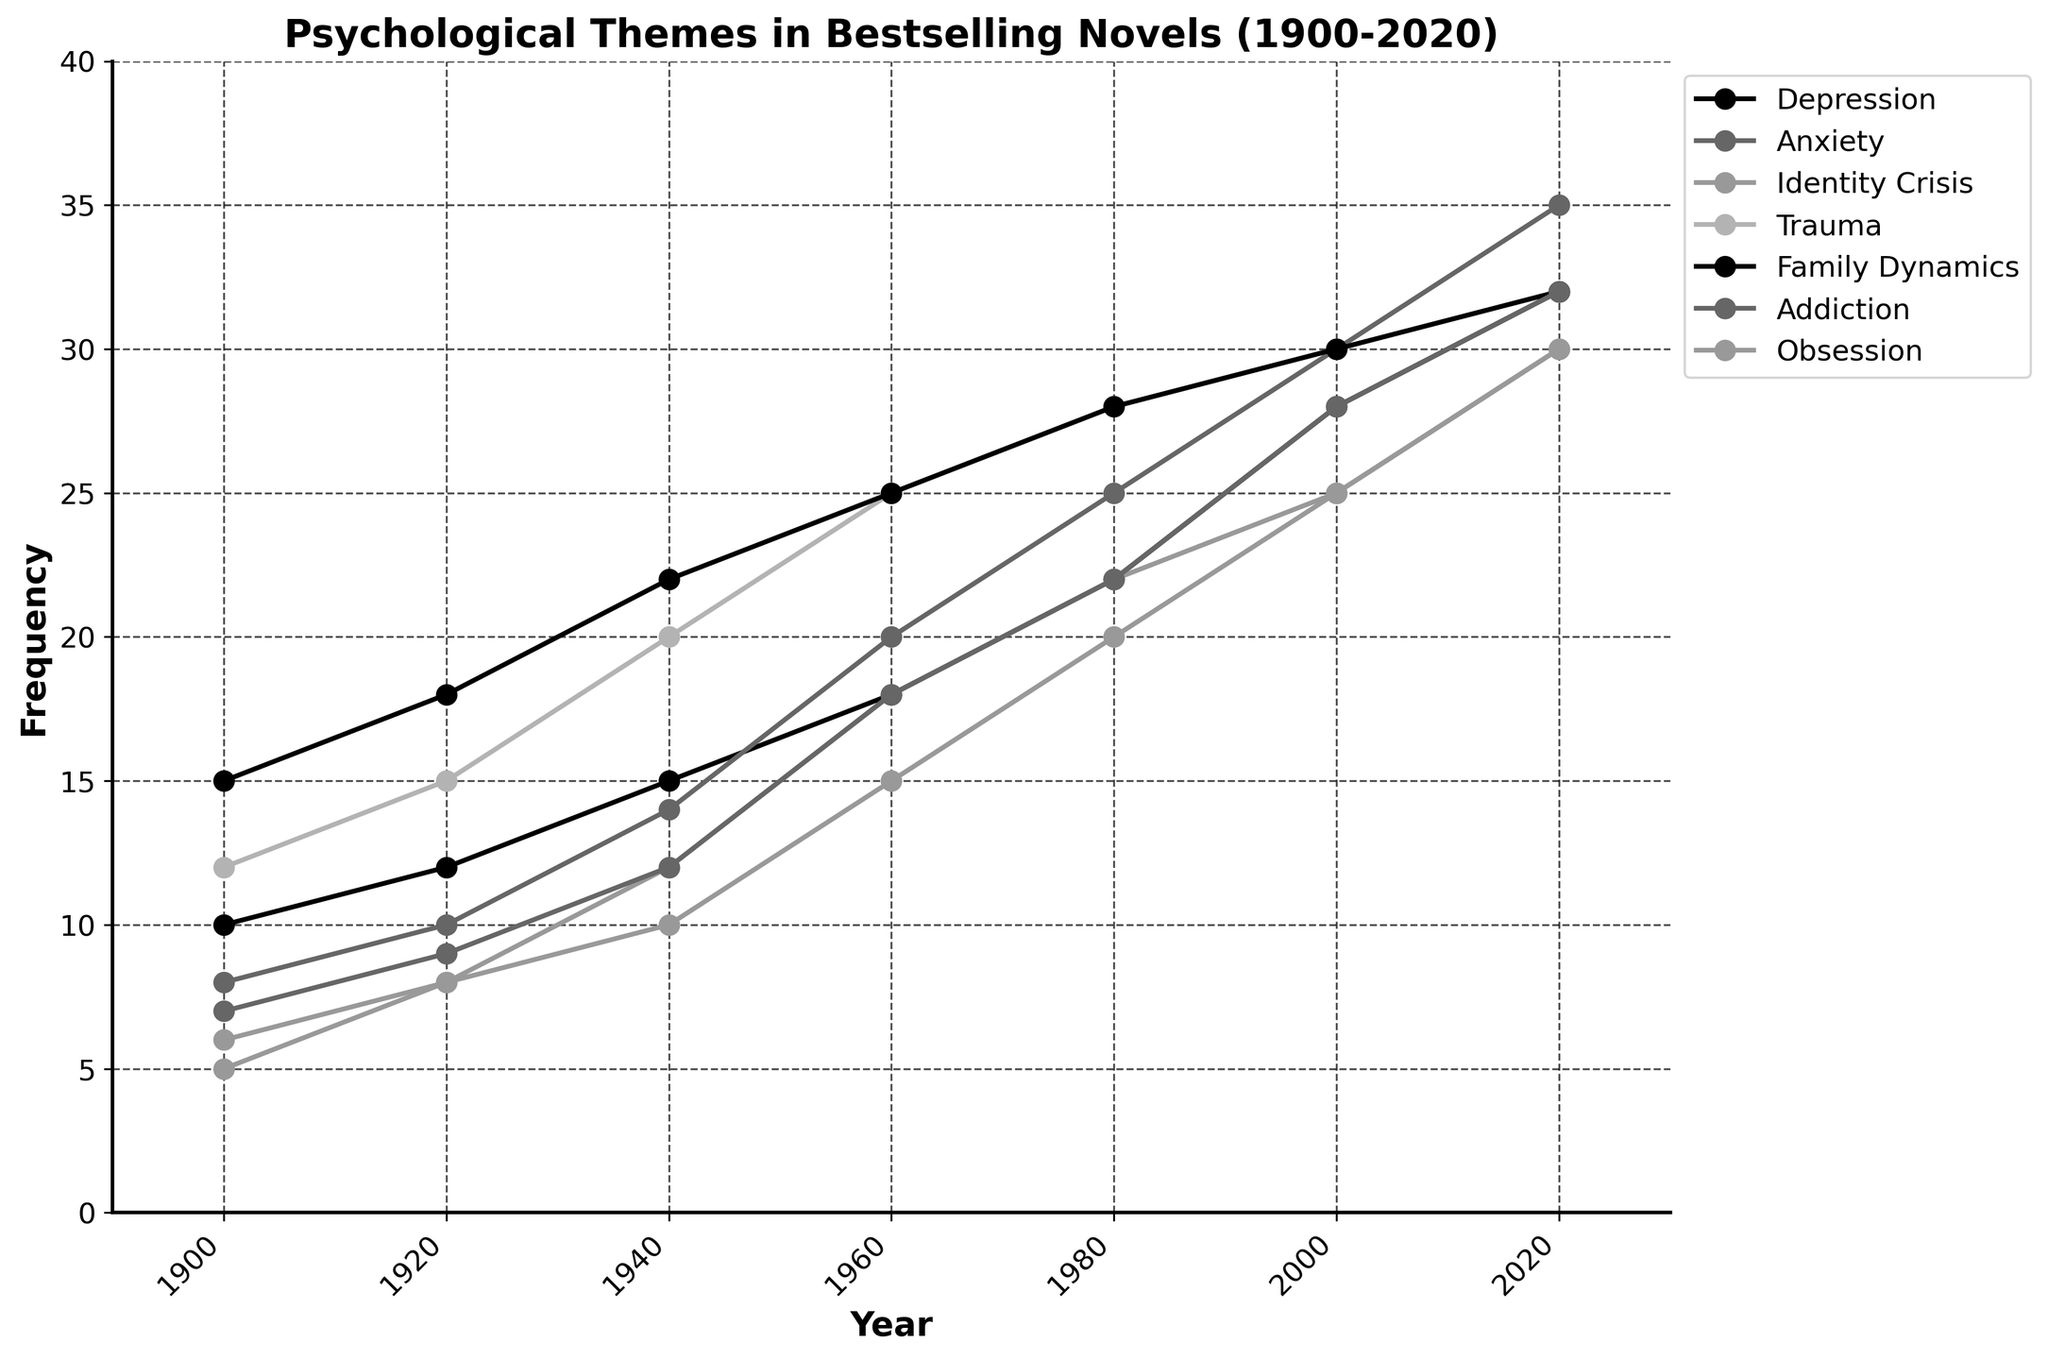What theme had the highest frequency in novels in 1930? To determine the highest frequency theme in 1930, we must refer to the plot and identify the maximum value for the year closest to 1930 (which is 1920). From the plot, Family Dynamics at 18 has the highest frequency.
Answer: Family Dynamics How did the frequency of Addiction change from 2000 to 2020? We start by looking at the frequency of Addiction in 2000, which is 28, and then look at it in 2020, which is 32. The change is 32 - 28 = 4.
Answer: Increased by 4 Which theme exhibited the most significant increase in frequency between 1900 and 2020? To find the theme with the most significant increase, calculate the difference between the frequencies in 2020 and 1900 for all themes. Depression: 32-10=22, Anxiety: 35-8=27, Identity Crisis: 30-5=25, Trauma: 32-12=20, Family Dynamics: 32-15=17, Addiction: 32-7=25, Obsession: 30-6=24. Anxiety has the highest increase of 27.
Answer: Anxiety What is the average frequency of Depression from 1900 to 2020? To find the average, sum the frequencies of Depression across all specified years, then divide by the number of years: (10+12+15+18+22+28+32)/7 = 137/7 ≈ 19.57.
Answer: 19.57 In which decade did Identity Crisis first exceed a frequency of 10? By examining the plot for each decade, Identity Crisis exceeds 10 for the first time between 1940 and 1960. Referring to the exact years: in 1940, Identity Crisis has a frequency of 12, which is above 10.
Answer: 1940s Between the years 1900 and 2000, which theme increased the least in frequency? Calculate the difference for each theme between 1900 and 2000: Depression: 28-10=18, Anxiety: 30-8=22, Identity Crisis: 25-5=20, Trauma: 30-12=18, Family Dynamics: 30-15=15, Addiction: 28-7=21, Obsession: 25-6=19. Family Dynamics increased the least by 15.
Answer: Family Dynamics Which themes show a consistent upward trend from 1900 to 2020? By observing the plot, Depression, Anxiety, Identity Crisis, Trauma, Family Dynamics, Addiction, and Obsession exhibit a consistent upward trend as their frequencies increase monotonically from 1900 to 2020.
Answer: All themes What was the difference in the frequency of Family Dynamics between 1960 and 1980? The frequency of Family Dynamics in 1960 was 25, and in 1980 it was 28. The difference is 28 - 25 = 3.
Answer: 3 In which year did Anxiety first reach a frequency of 30? Referring to the plot, Anxiety reached a frequency of 30 in the year 2000.
Answer: 2000 